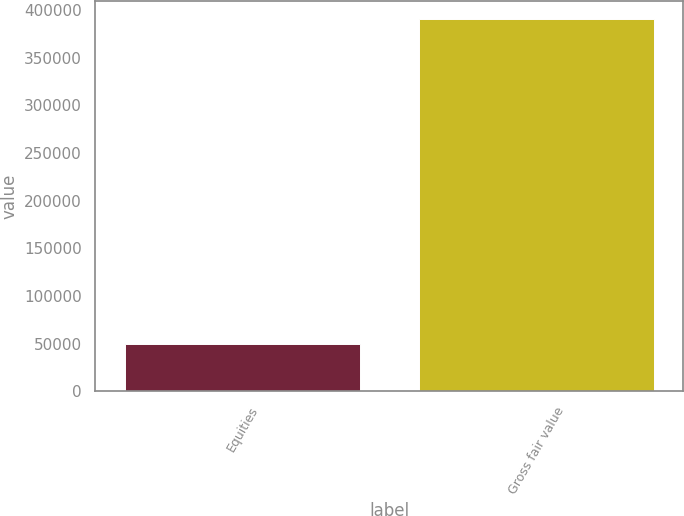<chart> <loc_0><loc_0><loc_500><loc_500><bar_chart><fcel>Equities<fcel>Gross fair value<nl><fcel>49910<fcel>390572<nl></chart> 